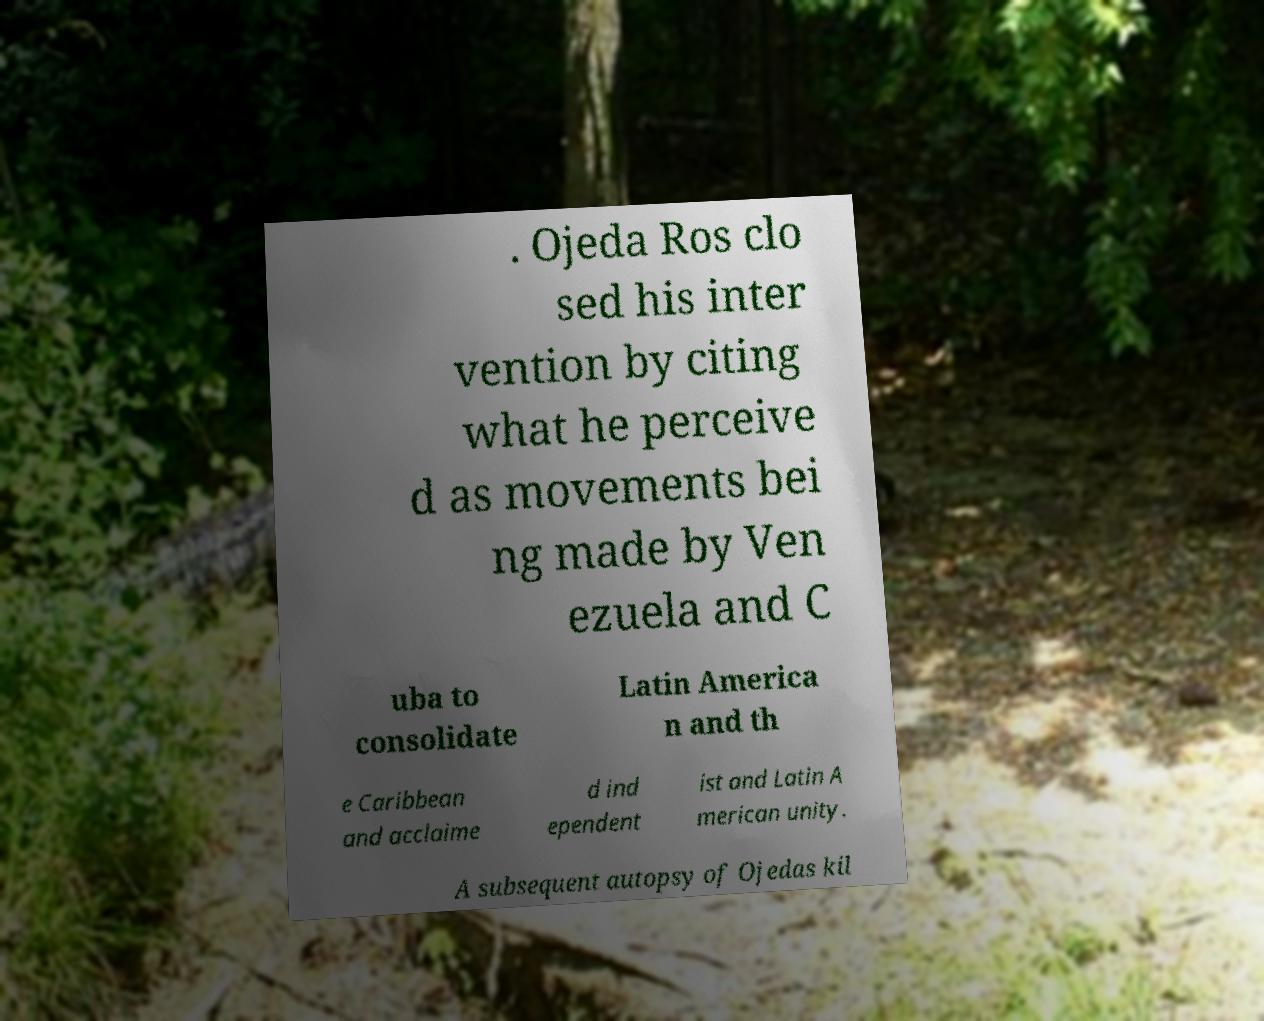For documentation purposes, I need the text within this image transcribed. Could you provide that? . Ojeda Ros clo sed his inter vention by citing what he perceive d as movements bei ng made by Ven ezuela and C uba to consolidate Latin America n and th e Caribbean and acclaime d ind ependent ist and Latin A merican unity. A subsequent autopsy of Ojedas kil 